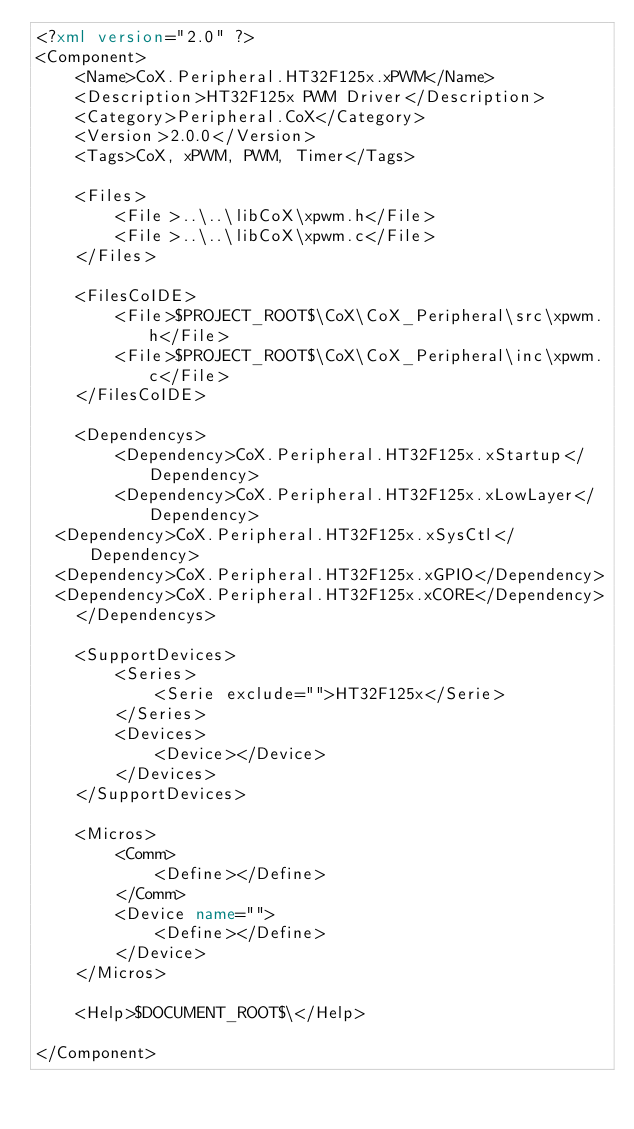<code> <loc_0><loc_0><loc_500><loc_500><_XML_><?xml version="2.0" ?>
<Component>
    <Name>CoX.Peripheral.HT32F125x.xPWM</Name>
    <Description>HT32F125x PWM Driver</Description>
    <Category>Peripheral.CoX</Category>
    <Version>2.0.0</Version>
    <Tags>CoX, xPWM, PWM, Timer</Tags>

    <Files>
        <File>..\..\libCoX\xpwm.h</File>
        <File>..\..\libCoX\xpwm.c</File>
    </Files>

    <FilesCoIDE>
        <File>$PROJECT_ROOT$\CoX\CoX_Peripheral\src\xpwm.h</File>
        <File>$PROJECT_ROOT$\CoX\CoX_Peripheral\inc\xpwm.c</File>
    </FilesCoIDE>

    <Dependencys>
        <Dependency>CoX.Peripheral.HT32F125x.xStartup</Dependency>
        <Dependency>CoX.Peripheral.HT32F125x.xLowLayer</Dependency>
	<Dependency>CoX.Peripheral.HT32F125x.xSysCtl</Dependency>
	<Dependency>CoX.Peripheral.HT32F125x.xGPIO</Dependency>
	<Dependency>CoX.Peripheral.HT32F125x.xCORE</Dependency>
    </Dependencys>

    <SupportDevices>
        <Series>
            <Serie exclude="">HT32F125x</Serie>
        </Series>
        <Devices>
            <Device></Device>
        </Devices>
    </SupportDevices>

    <Micros>
        <Comm>
            <Define></Define>
        </Comm>
        <Device name="">
            <Define></Define>
        </Device>   
    </Micros>

    <Help>$DOCUMENT_ROOT$\</Help>

</Component></code> 